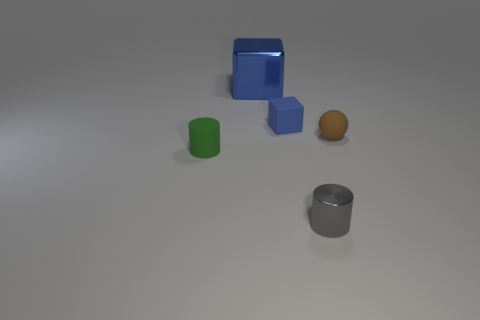What is the material of the tiny thing that is the same color as the large thing?
Offer a terse response. Rubber. Is the number of tiny blue rubber things less than the number of cylinders?
Offer a terse response. Yes. Are there any other things that are the same size as the blue metallic object?
Your answer should be compact. No. Is the big metallic object the same color as the tiny rubber block?
Ensure brevity in your answer.  Yes. Are there more small yellow rubber cubes than green objects?
Give a very brief answer. No. What number of other things are there of the same color as the small matte cube?
Offer a very short reply. 1. What number of large metallic blocks are to the right of the shiny thing in front of the small brown rubber ball?
Provide a short and direct response. 0. Are there any big things to the right of the tiny ball?
Provide a short and direct response. No. What shape is the rubber object that is to the right of the cylinder that is to the right of the tiny green rubber object?
Provide a succinct answer. Sphere. Are there fewer small spheres on the left side of the small blue object than big metal things left of the tiny matte cylinder?
Provide a succinct answer. No. 